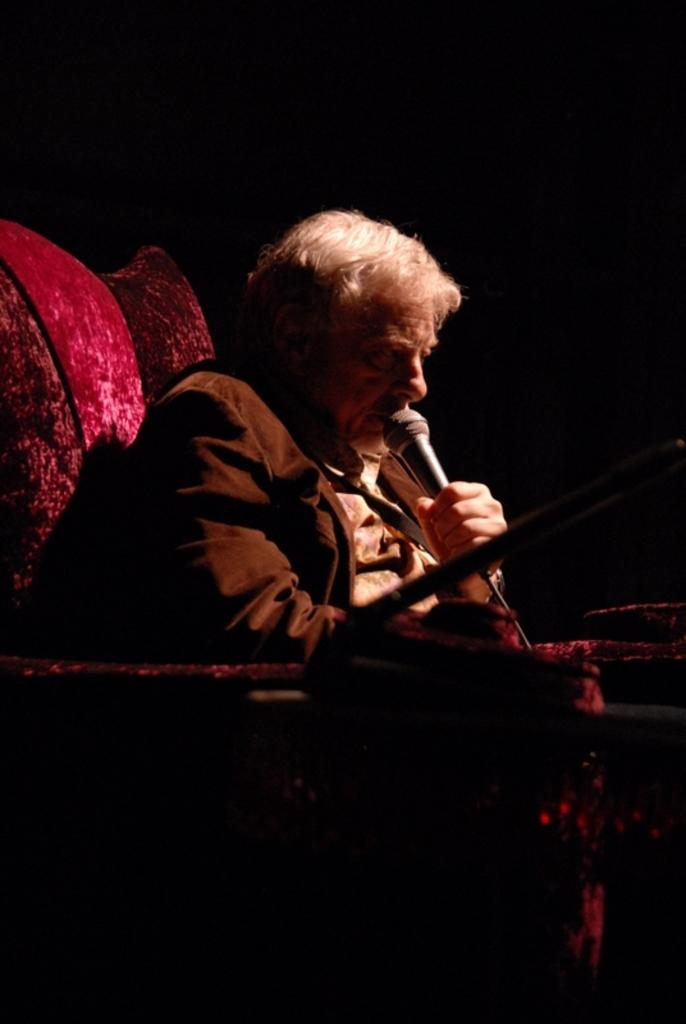Who is present in the image? There is a man in the image. What is the man doing in the image? The man is sitting on a couch and holding a microphone in his hand. What can be observed about the lighting in the image? The background of the image is dark. How many trees can be seen in the image? There are no trees visible in the image. What impulse might the man be experiencing while holding the microphone? The image does not provide information about the man's emotions or impulses, so it cannot be determined from the image. 